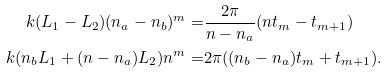<formula> <loc_0><loc_0><loc_500><loc_500>k ( L _ { 1 } - L _ { 2 } ) ( n _ { a } - n _ { b } ) ^ { m } = & \frac { 2 \pi } { n - n _ { a } } ( n t _ { m } - t _ { m + 1 } ) \\ k ( n _ { b } L _ { 1 } + ( n - n _ { a } ) L _ { 2 } ) n ^ { m } = & 2 \pi ( ( n _ { b } - n _ { a } ) t _ { m } + t _ { m + 1 } ) .</formula> 